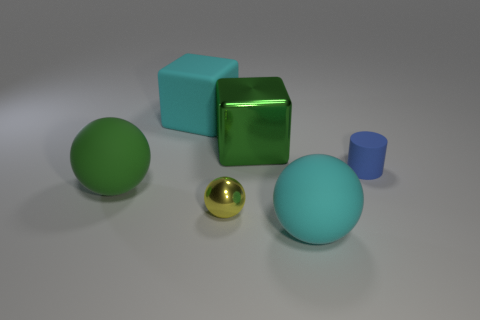What size is the object that is the same color as the big metallic block?
Your answer should be very brief. Large. Is there anything else that has the same size as the cyan sphere?
Provide a short and direct response. Yes. Do the big cyan block and the small yellow sphere have the same material?
Ensure brevity in your answer.  No. What number of things are things that are behind the small matte object or big objects in front of the big shiny cube?
Offer a very short reply. 4. Is there a metal object that has the same size as the shiny cube?
Provide a short and direct response. No. There is another large object that is the same shape as the large green metal object; what color is it?
Offer a terse response. Cyan. There is a metal object that is behind the big green ball; is there a big cyan matte block that is left of it?
Ensure brevity in your answer.  Yes. There is a cyan thing that is on the right side of the big cyan matte block; is it the same shape as the big green rubber thing?
Your response must be concise. Yes. What is the shape of the tiny yellow thing?
Ensure brevity in your answer.  Sphere. How many balls have the same material as the big green cube?
Offer a very short reply. 1. 